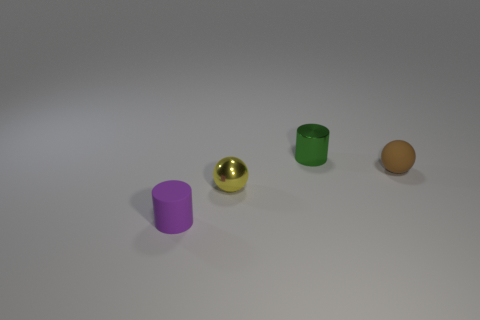Add 4 small gray rubber cylinders. How many objects exist? 8 Subtract all small brown balls. Subtract all spheres. How many objects are left? 1 Add 4 yellow balls. How many yellow balls are left? 5 Add 1 small red metal things. How many small red metal things exist? 1 Subtract 1 brown spheres. How many objects are left? 3 